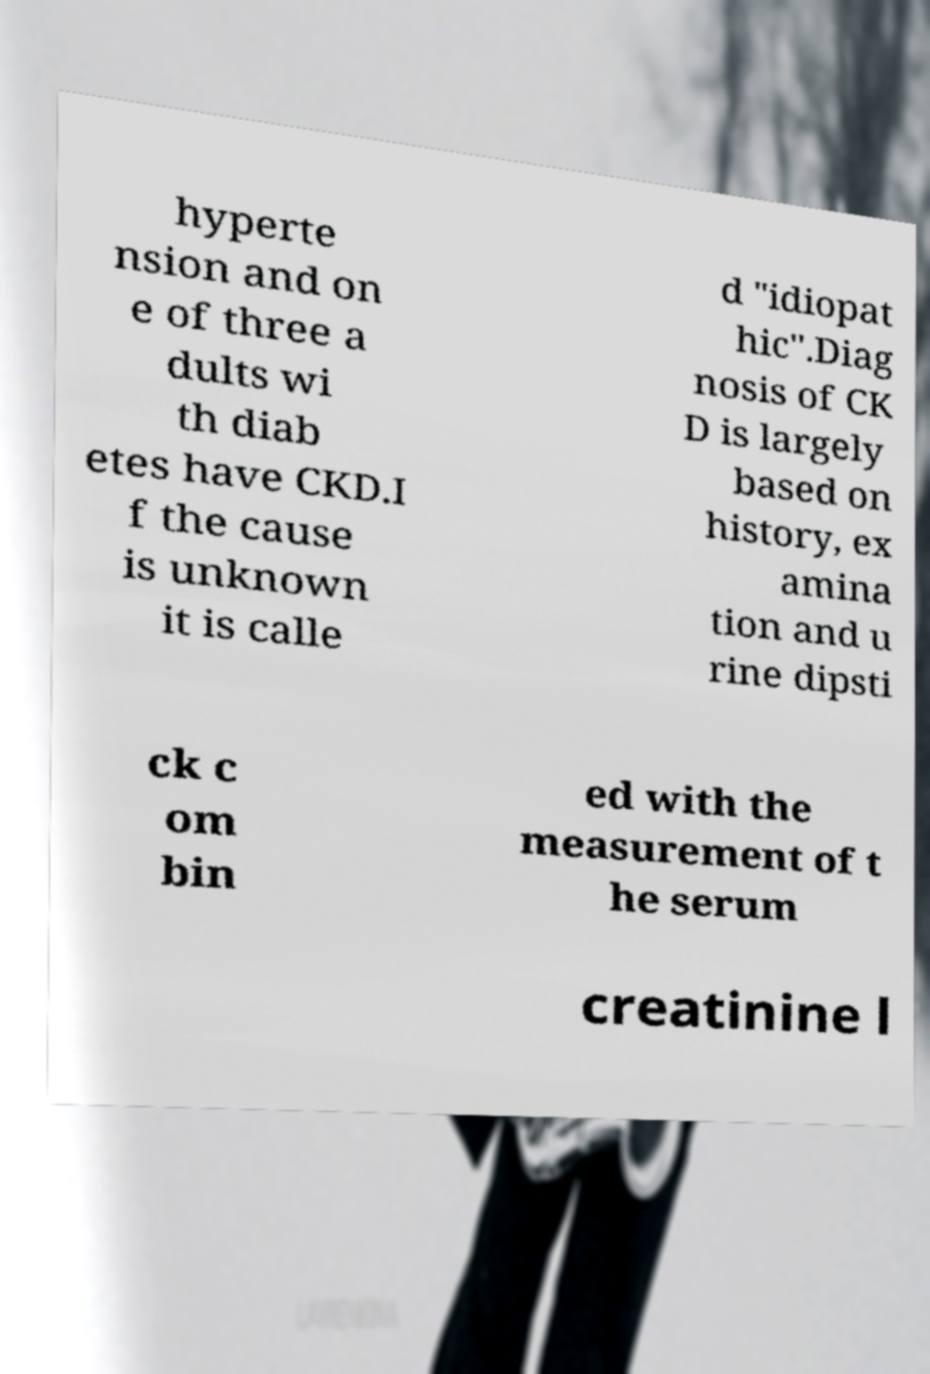Can you accurately transcribe the text from the provided image for me? hyperte nsion and on e of three a dults wi th diab etes have CKD.I f the cause is unknown it is calle d "idiopat hic".Diag nosis of CK D is largely based on history, ex amina tion and u rine dipsti ck c om bin ed with the measurement of t he serum creatinine l 